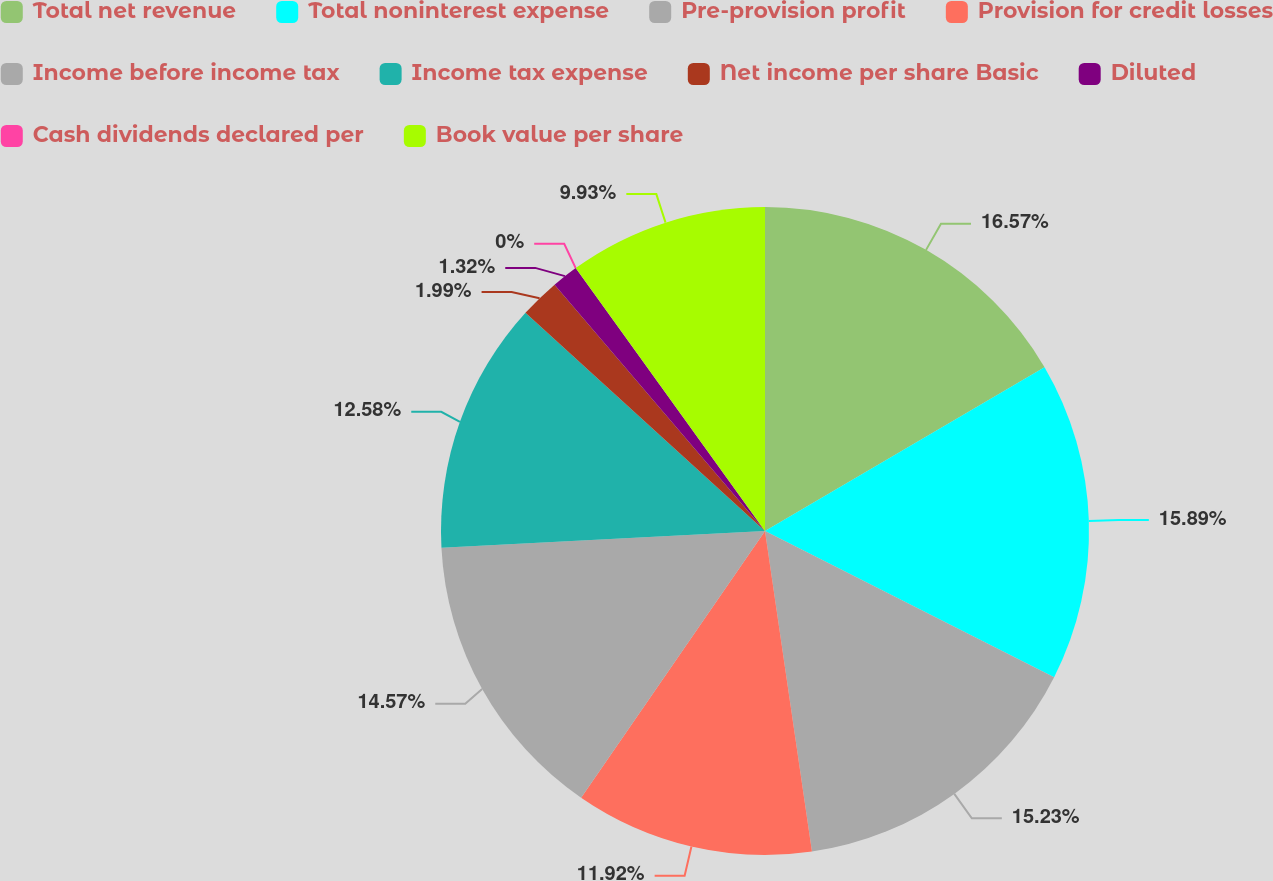<chart> <loc_0><loc_0><loc_500><loc_500><pie_chart><fcel>Total net revenue<fcel>Total noninterest expense<fcel>Pre-provision profit<fcel>Provision for credit losses<fcel>Income before income tax<fcel>Income tax expense<fcel>Net income per share Basic<fcel>Diluted<fcel>Cash dividends declared per<fcel>Book value per share<nl><fcel>16.56%<fcel>15.89%<fcel>15.23%<fcel>11.92%<fcel>14.57%<fcel>12.58%<fcel>1.99%<fcel>1.32%<fcel>0.0%<fcel>9.93%<nl></chart> 